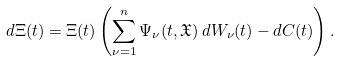Convert formula to latex. <formula><loc_0><loc_0><loc_500><loc_500>d \Xi ( t ) = \Xi ( t ) \left ( \sum _ { \nu = 1 } ^ { n } \Psi _ { \nu } ( t , \mathfrak { X } ) \, d W _ { \nu } ( t ) - d C ( t ) \right ) .</formula> 